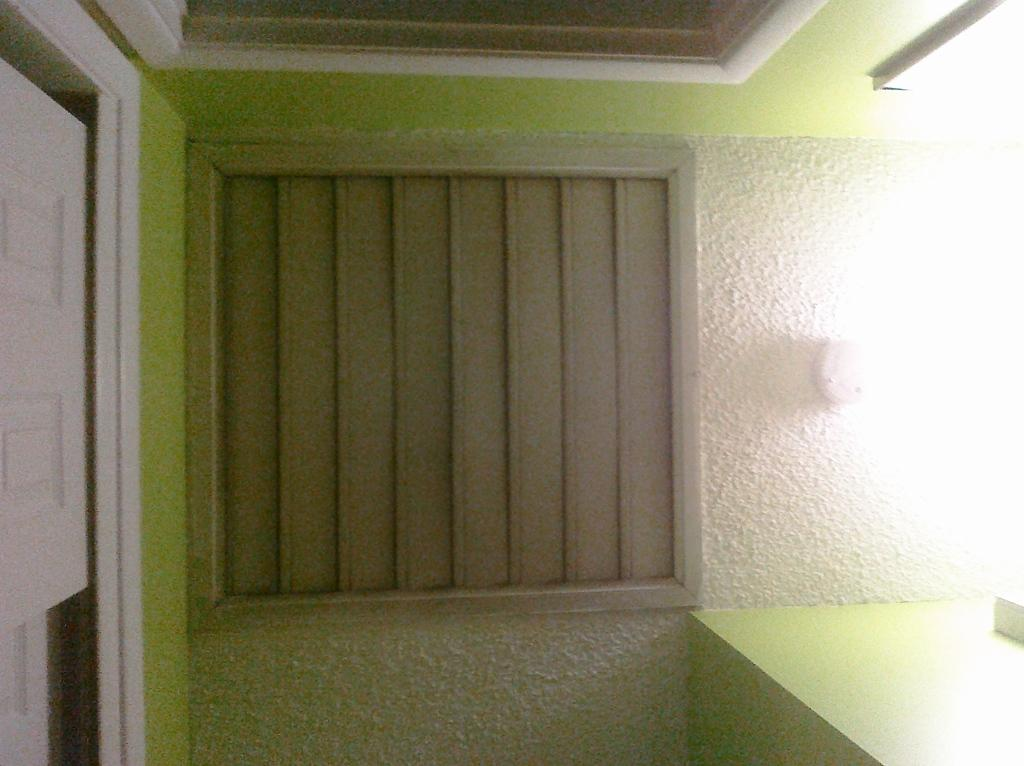What type of structure can be seen in the image? There is a wall in the image. What shape is the object in the image? A: The object in the image is square-shaped. Can you tell me how many bones are visible in the image? There are no bones present in the image; it only features a wall and a square-shaped object. What type of discovery can be made in the image? There is no discovery being made in the image; it simply shows a wall and a square-shaped object. 